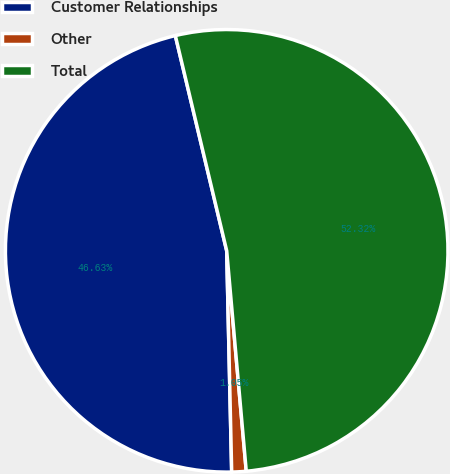Convert chart. <chart><loc_0><loc_0><loc_500><loc_500><pie_chart><fcel>Customer Relationships<fcel>Other<fcel>Total<nl><fcel>46.63%<fcel>1.05%<fcel>52.32%<nl></chart> 